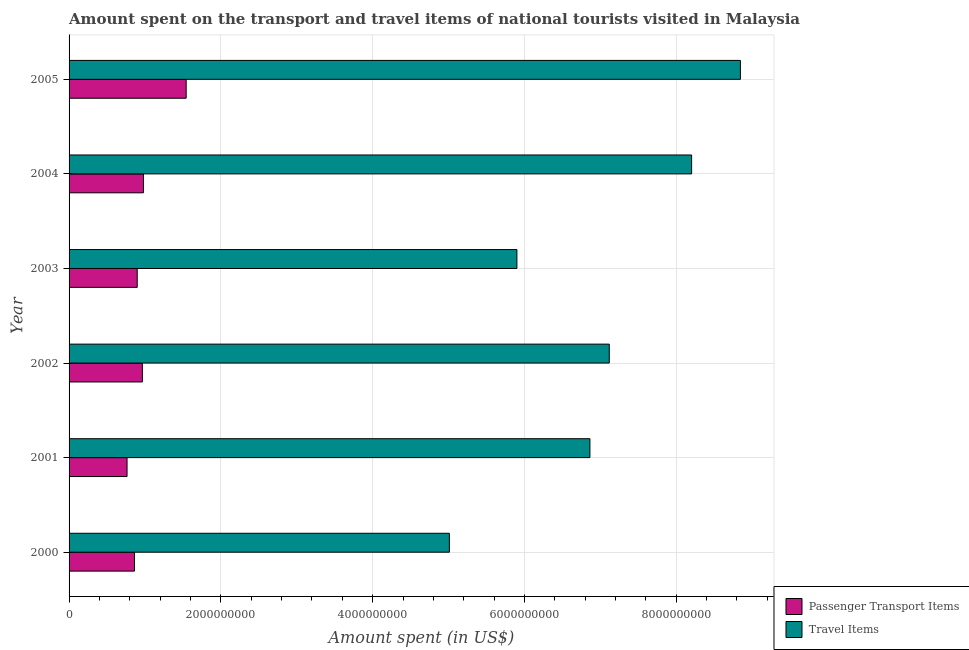How many different coloured bars are there?
Give a very brief answer. 2. Are the number of bars on each tick of the Y-axis equal?
Your answer should be compact. Yes. How many bars are there on the 4th tick from the top?
Give a very brief answer. 2. How many bars are there on the 5th tick from the bottom?
Make the answer very short. 2. What is the amount spent in travel items in 2002?
Your answer should be compact. 7.12e+09. Across all years, what is the maximum amount spent on passenger transport items?
Ensure brevity in your answer.  1.54e+09. Across all years, what is the minimum amount spent on passenger transport items?
Ensure brevity in your answer.  7.64e+08. In which year was the amount spent on passenger transport items maximum?
Provide a short and direct response. 2005. What is the total amount spent in travel items in the graph?
Offer a terse response. 4.19e+1. What is the difference between the amount spent on passenger transport items in 2002 and that in 2005?
Offer a terse response. -5.77e+08. What is the difference between the amount spent in travel items in 2005 and the amount spent on passenger transport items in 2000?
Offer a terse response. 7.98e+09. What is the average amount spent in travel items per year?
Keep it short and to the point. 6.99e+09. In the year 2000, what is the difference between the amount spent in travel items and amount spent on passenger transport items?
Your answer should be very brief. 4.15e+09. In how many years, is the amount spent in travel items greater than 5600000000 US$?
Give a very brief answer. 5. What is the ratio of the amount spent in travel items in 2003 to that in 2004?
Provide a short and direct response. 0.72. Is the amount spent in travel items in 2000 less than that in 2002?
Provide a succinct answer. Yes. What is the difference between the highest and the second highest amount spent in travel items?
Keep it short and to the point. 6.43e+08. What is the difference between the highest and the lowest amount spent on passenger transport items?
Make the answer very short. 7.79e+08. What does the 2nd bar from the top in 2004 represents?
Give a very brief answer. Passenger Transport Items. What does the 1st bar from the bottom in 2001 represents?
Your answer should be very brief. Passenger Transport Items. How many bars are there?
Provide a short and direct response. 12. Does the graph contain any zero values?
Make the answer very short. No. Where does the legend appear in the graph?
Your answer should be compact. Bottom right. How many legend labels are there?
Your answer should be compact. 2. How are the legend labels stacked?
Offer a very short reply. Vertical. What is the title of the graph?
Offer a terse response. Amount spent on the transport and travel items of national tourists visited in Malaysia. Does "National Visitors" appear as one of the legend labels in the graph?
Offer a very short reply. No. What is the label or title of the X-axis?
Your answer should be compact. Amount spent (in US$). What is the Amount spent (in US$) in Passenger Transport Items in 2000?
Give a very brief answer. 8.62e+08. What is the Amount spent (in US$) in Travel Items in 2000?
Give a very brief answer. 5.01e+09. What is the Amount spent (in US$) of Passenger Transport Items in 2001?
Your answer should be compact. 7.64e+08. What is the Amount spent (in US$) of Travel Items in 2001?
Ensure brevity in your answer.  6.86e+09. What is the Amount spent (in US$) of Passenger Transport Items in 2002?
Give a very brief answer. 9.66e+08. What is the Amount spent (in US$) of Travel Items in 2002?
Keep it short and to the point. 7.12e+09. What is the Amount spent (in US$) in Passenger Transport Items in 2003?
Your answer should be compact. 8.98e+08. What is the Amount spent (in US$) in Travel Items in 2003?
Your response must be concise. 5.90e+09. What is the Amount spent (in US$) of Passenger Transport Items in 2004?
Provide a succinct answer. 9.80e+08. What is the Amount spent (in US$) of Travel Items in 2004?
Your answer should be very brief. 8.20e+09. What is the Amount spent (in US$) of Passenger Transport Items in 2005?
Give a very brief answer. 1.54e+09. What is the Amount spent (in US$) of Travel Items in 2005?
Make the answer very short. 8.85e+09. Across all years, what is the maximum Amount spent (in US$) in Passenger Transport Items?
Your answer should be compact. 1.54e+09. Across all years, what is the maximum Amount spent (in US$) in Travel Items?
Your answer should be compact. 8.85e+09. Across all years, what is the minimum Amount spent (in US$) in Passenger Transport Items?
Make the answer very short. 7.64e+08. Across all years, what is the minimum Amount spent (in US$) in Travel Items?
Your answer should be compact. 5.01e+09. What is the total Amount spent (in US$) of Passenger Transport Items in the graph?
Your response must be concise. 6.01e+09. What is the total Amount spent (in US$) of Travel Items in the graph?
Your response must be concise. 4.19e+1. What is the difference between the Amount spent (in US$) of Passenger Transport Items in 2000 and that in 2001?
Make the answer very short. 9.80e+07. What is the difference between the Amount spent (in US$) of Travel Items in 2000 and that in 2001?
Keep it short and to the point. -1.85e+09. What is the difference between the Amount spent (in US$) in Passenger Transport Items in 2000 and that in 2002?
Make the answer very short. -1.04e+08. What is the difference between the Amount spent (in US$) of Travel Items in 2000 and that in 2002?
Your answer should be compact. -2.11e+09. What is the difference between the Amount spent (in US$) of Passenger Transport Items in 2000 and that in 2003?
Give a very brief answer. -3.60e+07. What is the difference between the Amount spent (in US$) in Travel Items in 2000 and that in 2003?
Keep it short and to the point. -8.90e+08. What is the difference between the Amount spent (in US$) in Passenger Transport Items in 2000 and that in 2004?
Offer a very short reply. -1.18e+08. What is the difference between the Amount spent (in US$) in Travel Items in 2000 and that in 2004?
Ensure brevity in your answer.  -3.19e+09. What is the difference between the Amount spent (in US$) of Passenger Transport Items in 2000 and that in 2005?
Make the answer very short. -6.81e+08. What is the difference between the Amount spent (in US$) of Travel Items in 2000 and that in 2005?
Your response must be concise. -3.84e+09. What is the difference between the Amount spent (in US$) in Passenger Transport Items in 2001 and that in 2002?
Keep it short and to the point. -2.02e+08. What is the difference between the Amount spent (in US$) in Travel Items in 2001 and that in 2002?
Give a very brief answer. -2.55e+08. What is the difference between the Amount spent (in US$) in Passenger Transport Items in 2001 and that in 2003?
Ensure brevity in your answer.  -1.34e+08. What is the difference between the Amount spent (in US$) in Travel Items in 2001 and that in 2003?
Your response must be concise. 9.62e+08. What is the difference between the Amount spent (in US$) of Passenger Transport Items in 2001 and that in 2004?
Give a very brief answer. -2.16e+08. What is the difference between the Amount spent (in US$) of Travel Items in 2001 and that in 2004?
Your response must be concise. -1.34e+09. What is the difference between the Amount spent (in US$) of Passenger Transport Items in 2001 and that in 2005?
Offer a terse response. -7.79e+08. What is the difference between the Amount spent (in US$) of Travel Items in 2001 and that in 2005?
Provide a short and direct response. -1.98e+09. What is the difference between the Amount spent (in US$) in Passenger Transport Items in 2002 and that in 2003?
Give a very brief answer. 6.80e+07. What is the difference between the Amount spent (in US$) in Travel Items in 2002 and that in 2003?
Keep it short and to the point. 1.22e+09. What is the difference between the Amount spent (in US$) in Passenger Transport Items in 2002 and that in 2004?
Keep it short and to the point. -1.40e+07. What is the difference between the Amount spent (in US$) of Travel Items in 2002 and that in 2004?
Your answer should be very brief. -1.08e+09. What is the difference between the Amount spent (in US$) of Passenger Transport Items in 2002 and that in 2005?
Provide a succinct answer. -5.77e+08. What is the difference between the Amount spent (in US$) in Travel Items in 2002 and that in 2005?
Your answer should be very brief. -1.73e+09. What is the difference between the Amount spent (in US$) of Passenger Transport Items in 2003 and that in 2004?
Provide a short and direct response. -8.20e+07. What is the difference between the Amount spent (in US$) in Travel Items in 2003 and that in 2004?
Your answer should be compact. -2.30e+09. What is the difference between the Amount spent (in US$) of Passenger Transport Items in 2003 and that in 2005?
Give a very brief answer. -6.45e+08. What is the difference between the Amount spent (in US$) in Travel Items in 2003 and that in 2005?
Your response must be concise. -2.94e+09. What is the difference between the Amount spent (in US$) of Passenger Transport Items in 2004 and that in 2005?
Ensure brevity in your answer.  -5.63e+08. What is the difference between the Amount spent (in US$) of Travel Items in 2004 and that in 2005?
Offer a very short reply. -6.43e+08. What is the difference between the Amount spent (in US$) in Passenger Transport Items in 2000 and the Amount spent (in US$) in Travel Items in 2001?
Your answer should be compact. -6.00e+09. What is the difference between the Amount spent (in US$) of Passenger Transport Items in 2000 and the Amount spent (in US$) of Travel Items in 2002?
Ensure brevity in your answer.  -6.26e+09. What is the difference between the Amount spent (in US$) of Passenger Transport Items in 2000 and the Amount spent (in US$) of Travel Items in 2003?
Make the answer very short. -5.04e+09. What is the difference between the Amount spent (in US$) of Passenger Transport Items in 2000 and the Amount spent (in US$) of Travel Items in 2004?
Your response must be concise. -7.34e+09. What is the difference between the Amount spent (in US$) of Passenger Transport Items in 2000 and the Amount spent (in US$) of Travel Items in 2005?
Your response must be concise. -7.98e+09. What is the difference between the Amount spent (in US$) of Passenger Transport Items in 2001 and the Amount spent (in US$) of Travel Items in 2002?
Your answer should be very brief. -6.35e+09. What is the difference between the Amount spent (in US$) of Passenger Transport Items in 2001 and the Amount spent (in US$) of Travel Items in 2003?
Your answer should be very brief. -5.14e+09. What is the difference between the Amount spent (in US$) of Passenger Transport Items in 2001 and the Amount spent (in US$) of Travel Items in 2004?
Provide a short and direct response. -7.44e+09. What is the difference between the Amount spent (in US$) in Passenger Transport Items in 2001 and the Amount spent (in US$) in Travel Items in 2005?
Make the answer very short. -8.08e+09. What is the difference between the Amount spent (in US$) of Passenger Transport Items in 2002 and the Amount spent (in US$) of Travel Items in 2003?
Provide a succinct answer. -4.94e+09. What is the difference between the Amount spent (in US$) of Passenger Transport Items in 2002 and the Amount spent (in US$) of Travel Items in 2004?
Your answer should be very brief. -7.24e+09. What is the difference between the Amount spent (in US$) in Passenger Transport Items in 2002 and the Amount spent (in US$) in Travel Items in 2005?
Your answer should be compact. -7.88e+09. What is the difference between the Amount spent (in US$) of Passenger Transport Items in 2003 and the Amount spent (in US$) of Travel Items in 2004?
Provide a short and direct response. -7.30e+09. What is the difference between the Amount spent (in US$) of Passenger Transport Items in 2003 and the Amount spent (in US$) of Travel Items in 2005?
Offer a terse response. -7.95e+09. What is the difference between the Amount spent (in US$) in Passenger Transport Items in 2004 and the Amount spent (in US$) in Travel Items in 2005?
Your response must be concise. -7.87e+09. What is the average Amount spent (in US$) in Passenger Transport Items per year?
Provide a succinct answer. 1.00e+09. What is the average Amount spent (in US$) of Travel Items per year?
Your response must be concise. 6.99e+09. In the year 2000, what is the difference between the Amount spent (in US$) of Passenger Transport Items and Amount spent (in US$) of Travel Items?
Make the answer very short. -4.15e+09. In the year 2001, what is the difference between the Amount spent (in US$) of Passenger Transport Items and Amount spent (in US$) of Travel Items?
Keep it short and to the point. -6.10e+09. In the year 2002, what is the difference between the Amount spent (in US$) of Passenger Transport Items and Amount spent (in US$) of Travel Items?
Offer a terse response. -6.15e+09. In the year 2003, what is the difference between the Amount spent (in US$) in Passenger Transport Items and Amount spent (in US$) in Travel Items?
Make the answer very short. -5.00e+09. In the year 2004, what is the difference between the Amount spent (in US$) in Passenger Transport Items and Amount spent (in US$) in Travel Items?
Your answer should be very brief. -7.22e+09. In the year 2005, what is the difference between the Amount spent (in US$) of Passenger Transport Items and Amount spent (in US$) of Travel Items?
Keep it short and to the point. -7.30e+09. What is the ratio of the Amount spent (in US$) in Passenger Transport Items in 2000 to that in 2001?
Provide a short and direct response. 1.13. What is the ratio of the Amount spent (in US$) of Travel Items in 2000 to that in 2001?
Give a very brief answer. 0.73. What is the ratio of the Amount spent (in US$) in Passenger Transport Items in 2000 to that in 2002?
Keep it short and to the point. 0.89. What is the ratio of the Amount spent (in US$) in Travel Items in 2000 to that in 2002?
Keep it short and to the point. 0.7. What is the ratio of the Amount spent (in US$) in Passenger Transport Items in 2000 to that in 2003?
Your answer should be very brief. 0.96. What is the ratio of the Amount spent (in US$) in Travel Items in 2000 to that in 2003?
Make the answer very short. 0.85. What is the ratio of the Amount spent (in US$) of Passenger Transport Items in 2000 to that in 2004?
Your answer should be very brief. 0.88. What is the ratio of the Amount spent (in US$) in Travel Items in 2000 to that in 2004?
Your response must be concise. 0.61. What is the ratio of the Amount spent (in US$) in Passenger Transport Items in 2000 to that in 2005?
Keep it short and to the point. 0.56. What is the ratio of the Amount spent (in US$) of Travel Items in 2000 to that in 2005?
Offer a very short reply. 0.57. What is the ratio of the Amount spent (in US$) in Passenger Transport Items in 2001 to that in 2002?
Make the answer very short. 0.79. What is the ratio of the Amount spent (in US$) of Travel Items in 2001 to that in 2002?
Your answer should be compact. 0.96. What is the ratio of the Amount spent (in US$) in Passenger Transport Items in 2001 to that in 2003?
Your response must be concise. 0.85. What is the ratio of the Amount spent (in US$) of Travel Items in 2001 to that in 2003?
Ensure brevity in your answer.  1.16. What is the ratio of the Amount spent (in US$) of Passenger Transport Items in 2001 to that in 2004?
Provide a short and direct response. 0.78. What is the ratio of the Amount spent (in US$) of Travel Items in 2001 to that in 2004?
Provide a short and direct response. 0.84. What is the ratio of the Amount spent (in US$) of Passenger Transport Items in 2001 to that in 2005?
Your response must be concise. 0.5. What is the ratio of the Amount spent (in US$) in Travel Items in 2001 to that in 2005?
Provide a short and direct response. 0.78. What is the ratio of the Amount spent (in US$) of Passenger Transport Items in 2002 to that in 2003?
Ensure brevity in your answer.  1.08. What is the ratio of the Amount spent (in US$) of Travel Items in 2002 to that in 2003?
Your answer should be very brief. 1.21. What is the ratio of the Amount spent (in US$) in Passenger Transport Items in 2002 to that in 2004?
Your answer should be very brief. 0.99. What is the ratio of the Amount spent (in US$) in Travel Items in 2002 to that in 2004?
Your answer should be compact. 0.87. What is the ratio of the Amount spent (in US$) in Passenger Transport Items in 2002 to that in 2005?
Your response must be concise. 0.63. What is the ratio of the Amount spent (in US$) in Travel Items in 2002 to that in 2005?
Your response must be concise. 0.8. What is the ratio of the Amount spent (in US$) of Passenger Transport Items in 2003 to that in 2004?
Provide a succinct answer. 0.92. What is the ratio of the Amount spent (in US$) in Travel Items in 2003 to that in 2004?
Offer a very short reply. 0.72. What is the ratio of the Amount spent (in US$) of Passenger Transport Items in 2003 to that in 2005?
Your answer should be compact. 0.58. What is the ratio of the Amount spent (in US$) in Travel Items in 2003 to that in 2005?
Provide a short and direct response. 0.67. What is the ratio of the Amount spent (in US$) of Passenger Transport Items in 2004 to that in 2005?
Your answer should be very brief. 0.64. What is the ratio of the Amount spent (in US$) in Travel Items in 2004 to that in 2005?
Your answer should be compact. 0.93. What is the difference between the highest and the second highest Amount spent (in US$) of Passenger Transport Items?
Your response must be concise. 5.63e+08. What is the difference between the highest and the second highest Amount spent (in US$) in Travel Items?
Offer a very short reply. 6.43e+08. What is the difference between the highest and the lowest Amount spent (in US$) of Passenger Transport Items?
Provide a succinct answer. 7.79e+08. What is the difference between the highest and the lowest Amount spent (in US$) of Travel Items?
Offer a terse response. 3.84e+09. 